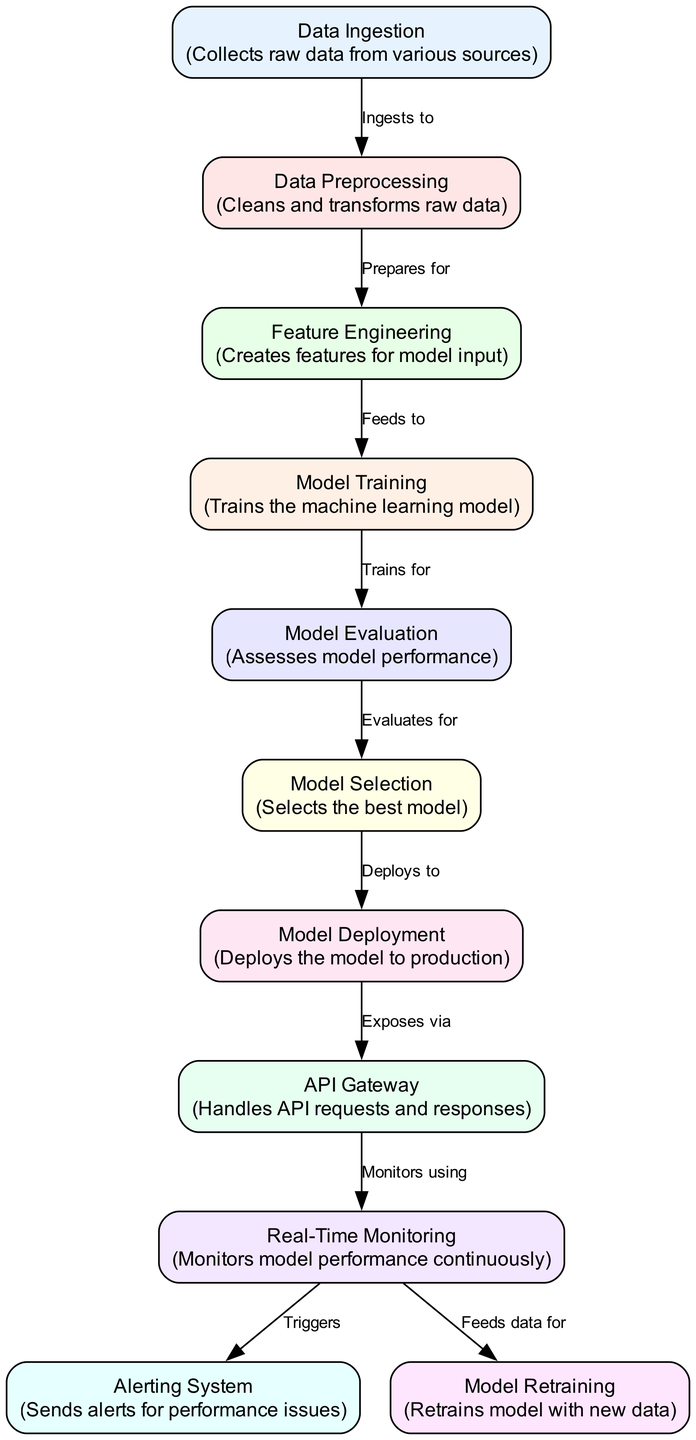What is the first node in the pipeline? The first node in the pipeline, as depicted in the diagram, is labeled "Data Ingestion." This node is responsible for collecting raw data from various sources, and it is positioned at the top of the flow.
Answer: Data Ingestion How many nodes are in the diagram? To find the total number of nodes, we can count the nodes listed. There are a total of 11 nodes in the diagram, each representing a different step in the machine learning deployment pipeline.
Answer: 11 What does the "API Gateway" node do? The "API Gateway" node handles API requests and responses. This function allows the model to be accessible for external queries after deployment. It acts as an intermediary between the deployed model and the clients or applications requesting its services.
Answer: Handles API requests and responses Which node follows "Model Evaluation"? The node that follows "Model Evaluation" is "Model Selection." This transition indicates that after evaluating the model's performance, the best-performing model is selected for deployment.
Answer: Model Selection What is the main purpose of the "Real-Time Monitoring"? The primary purpose of the "Real-Time Monitoring" node is to continuously monitor model performance. This ongoing assessment ensures that the model operates effectively over time, allowing for quick responses to any changes in performance.
Answer: Monitors model performance continuously What triggers the "Alerting System"? The "Alerting System" is triggered by the "Real-Time Monitoring" node. When the monitoring system detects performance issues or anomalies, it sends alerts through the alerting system to notify the relevant stakeholders or systems.
Answer: Triggers from Real-Time Monitoring What feeds data for "Model Retraining"? The node that feeds data for "Model Retraining" is "Real-Time Monitoring." As the model is monitored in real time, the collected data is utilized for retraining the model to improve its performance with new information.
Answer: Real-Time Monitoring Which part of the diagram deals with model performance issues? The part of the diagram that deals specifically with model performance issues includes the "Real-Time Monitoring" node and the "Alerting System" node. These components work together to ensure that model performance is continuously assessed and any issues are promptly addressed.
Answer: Real-Time Monitoring and Alerting System What comes after "Model Training"? After "Model Training," the next step is "Model Evaluation." This transition indicates that once the model has been trained, its performance is evaluated before deciding on the next steps in the process.
Answer: Model Evaluation 